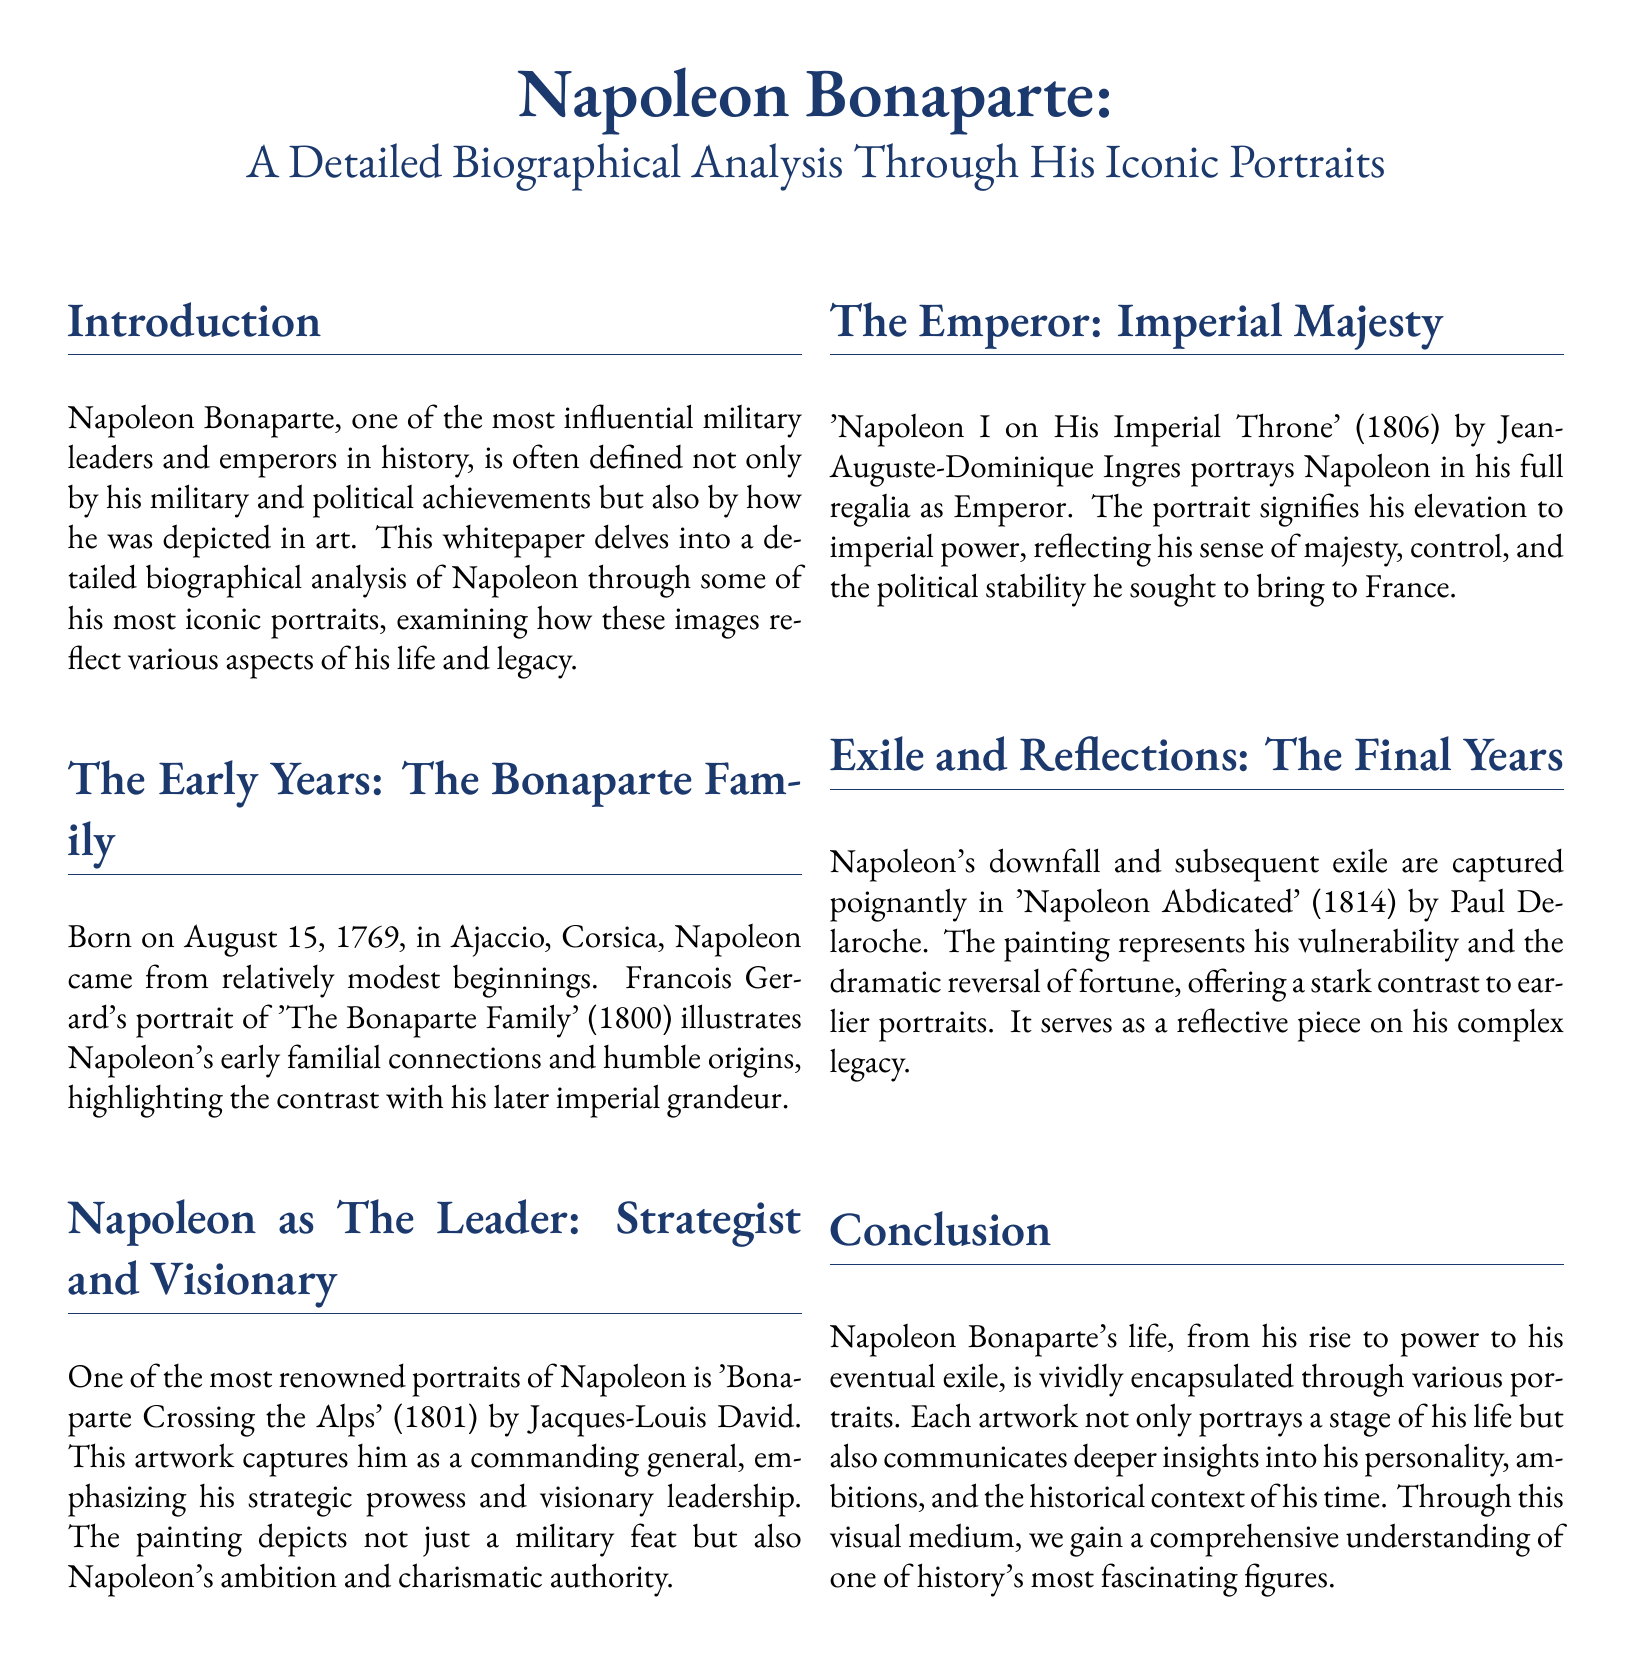What is Napoleon's date of birth? The document states that Napoleon was born on August 15, 1769.
Answer: August 15, 1769 Who painted 'Bonaparte Crossing the Alps'? The document mentions that Jacques-Louis David painted 'Bonaparte Crossing the Alps' in 1801.
Answer: Jacques-Louis David What does the portrait 'Napoleon I on His Imperial Throne' signify? The document describes that this portrait signifies Napoleon's elevation to imperial power and reflects his sense of majesty.
Answer: Elevation to imperial power In what year was 'Napoleon Abdicated' painted? According to the document, 'Napoleon Abdicated' was painted in 1814.
Answer: 1814 What aspect of Napoleon's life is highlighted in his early familial connections portrait? The document notes that the portrait illustrates humble origins and familial connections.
Answer: Humble origins What does 'Napoleon Abdicated' reflect about Napoleon? The document states that it reflects his vulnerability and dramatic reversal of fortune.
Answer: Vulnerability What theme is explored in the portraits of Napoleon? The document indicates that the portraits explore themes related to his life stages and historical context.
Answer: Life stages How does the document categorize itself? The document introduces itself as a whitepaper focusing on Napoleon through his iconic portraits.
Answer: Whitepaper 